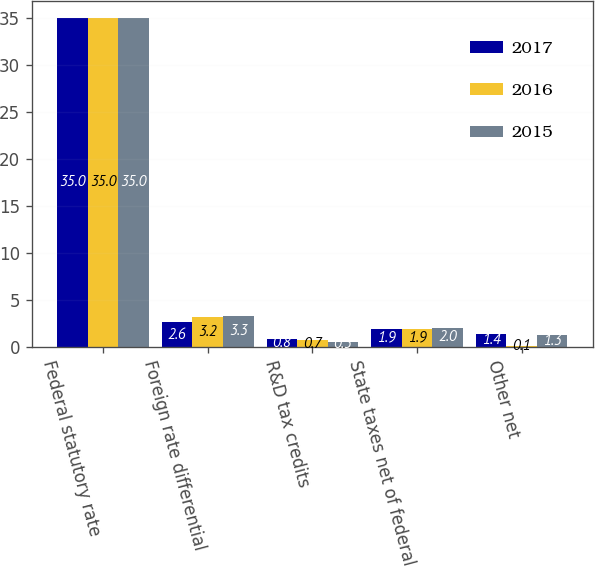<chart> <loc_0><loc_0><loc_500><loc_500><stacked_bar_chart><ecel><fcel>Federal statutory rate<fcel>Foreign rate differential<fcel>R&D tax credits<fcel>State taxes net of federal<fcel>Other net<nl><fcel>2017<fcel>35<fcel>2.6<fcel>0.8<fcel>1.9<fcel>1.4<nl><fcel>2016<fcel>35<fcel>3.2<fcel>0.7<fcel>1.9<fcel>0.1<nl><fcel>2015<fcel>35<fcel>3.3<fcel>0.5<fcel>2<fcel>1.3<nl></chart> 